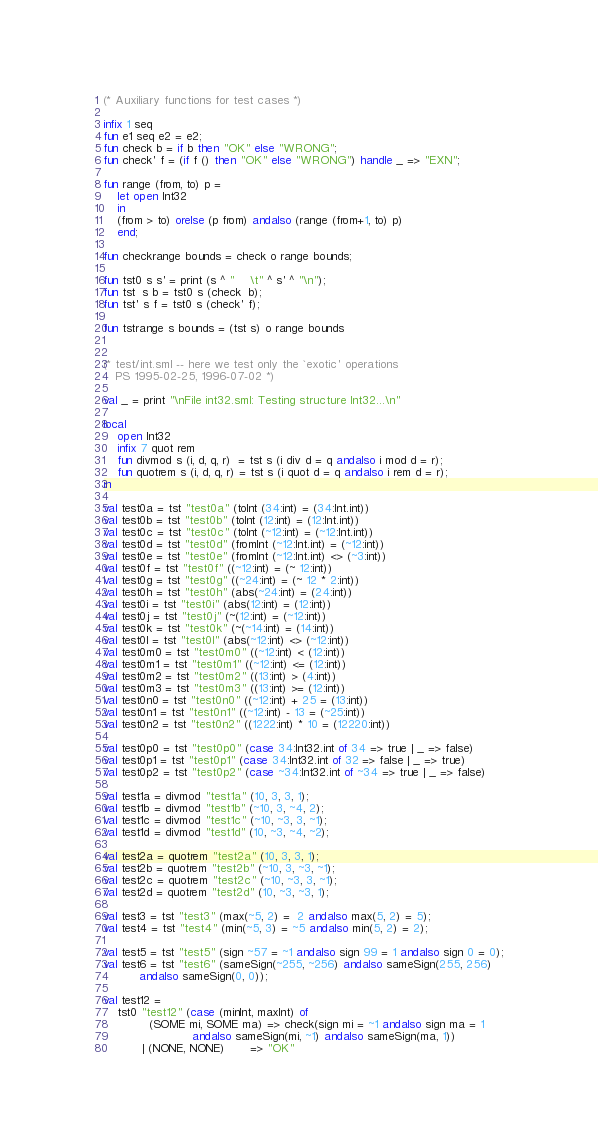<code> <loc_0><loc_0><loc_500><loc_500><_SML_>(* Auxiliary functions for test cases *)

infix 1 seq
fun e1 seq e2 = e2;
fun check b = if b then "OK" else "WRONG";
fun check' f = (if f () then "OK" else "WRONG") handle _ => "EXN";

fun range (from, to) p = 
    let open Int32
    in
	(from > to) orelse (p from) andalso (range (from+1, to) p)
    end;

fun checkrange bounds = check o range bounds;

fun tst0 s s' = print (s ^ "    \t" ^ s' ^ "\n");
fun tst  s b = tst0 s (check  b);
fun tst' s f = tst0 s (check' f);

fun tstrange s bounds = (tst s) o range bounds  


(* test/int.sml -- here we test only the `exotic' operations
   PS 1995-02-25, 1996-07-02 *)

val _ = print "\nFile int32.sml: Testing structure Int32...\n"

local 
    open Int32
    infix 7 quot rem
    fun divmod s (i, d, q, r)  = tst s (i div d = q andalso i mod d = r);
    fun quotrem s (i, d, q, r) = tst s (i quot d = q andalso i rem d = r);
in	

val test0a = tst "test0a" (toInt (34:int) = (34:Int.int))
val test0b = tst "test0b" (toInt (12:int) = (12:Int.int))
val test0c = tst "test0c" (toInt (~12:int) = (~12:Int.int))
val test0d = tst "test0d" (fromInt (~12:Int.int) = (~12:int))
val test0e = tst "test0e" (fromInt (~12:Int.int) <> (~3:int))
val test0f = tst "test0f" ((~12:int) = (~ 12:int))
val test0g = tst "test0g" ((~24:int) = (~ 12 * 2:int))
val test0h = tst "test0h" (abs(~24:int) = (24:int))
val test0i = tst "test0i" (abs(12:int) = (12:int))
val test0j = tst "test0j" (~(12:int) = (~12:int))
val test0k = tst "test0k" (~(~14:int) = (14:int))
val test0l = tst "test0l" (abs(~12:int) <> (~12:int))
val test0m0 = tst "test0m0" ((~12:int) < (12:int))
val test0m1 = tst "test0m1" ((~12:int) <= (12:int))
val test0m2 = tst "test0m2" ((13:int) > (4:int))
val test0m3 = tst "test0m3" ((13:int) >= (12:int))
val test0n0 = tst "test0n0" ((~12:int) + 25 = (13:int))
val test0n1 = tst "test0n1" ((~12:int) - 13 = (~25:int))
val test0n2 = tst "test0n2" ((1222:int) * 10 = (12220:int))

val test0p0 = tst "test0p0" (case 34:Int32.int of 34 => true | _ => false)
val test0p1 = tst "test0p1" (case 34:Int32.int of 32 => false | _ => true)
val test0p2 = tst "test0p2" (case ~34:Int32.int of ~34 => true | _ => false)

val test1a = divmod "test1a" (10, 3, 3, 1);
val test1b = divmod "test1b" (~10, 3, ~4, 2);
val test1c = divmod "test1c" (~10, ~3, 3, ~1);
val test1d = divmod "test1d" (10, ~3, ~4, ~2);

val test2a = quotrem "test2a" (10, 3, 3, 1);
val test2b = quotrem "test2b" (~10, 3, ~3, ~1);
val test2c = quotrem "test2c" (~10, ~3, 3, ~1);
val test2d = quotrem "test2d" (10, ~3, ~3, 1);

val test3 = tst "test3" (max(~5, 2) =  2 andalso max(5, 2) = 5);
val test4 = tst "test4" (min(~5, 3) = ~5 andalso min(5, 2) = 2);

val test5 = tst "test5" (sign ~57 = ~1 andalso sign 99 = 1 andalso sign 0 = 0);
val test6 = tst "test6" (sameSign(~255, ~256) andalso sameSign(255, 256) 
		  andalso sameSign(0, 0));

val test12 = 
    tst0 "test12" (case (minInt, maxInt) of
		     (SOME mi, SOME ma) => check(sign mi = ~1 andalso sign ma = 1 
						 andalso sameSign(mi, ~1) andalso sameSign(ma, 1))
		   | (NONE, NONE)       => "OK"</code> 